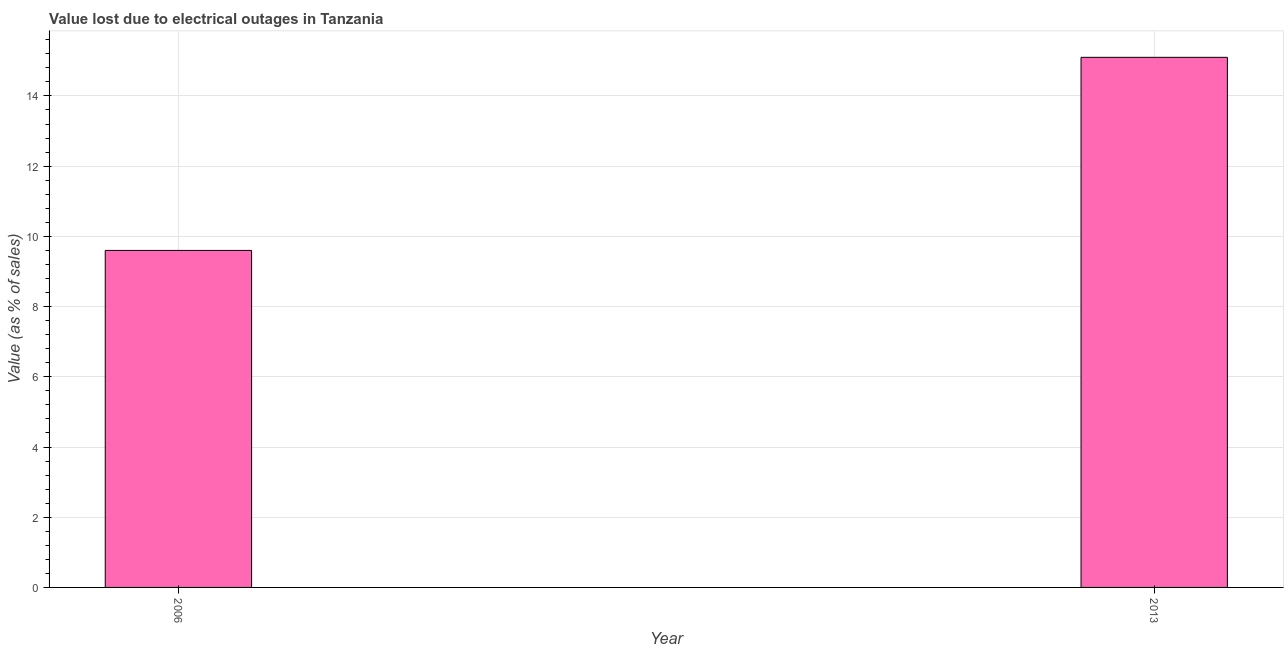Does the graph contain any zero values?
Offer a very short reply. No. Does the graph contain grids?
Offer a terse response. Yes. What is the title of the graph?
Make the answer very short. Value lost due to electrical outages in Tanzania. What is the label or title of the X-axis?
Make the answer very short. Year. What is the label or title of the Y-axis?
Your answer should be compact. Value (as % of sales). Across all years, what is the maximum value lost due to electrical outages?
Make the answer very short. 15.1. In which year was the value lost due to electrical outages maximum?
Provide a short and direct response. 2013. In which year was the value lost due to electrical outages minimum?
Provide a succinct answer. 2006. What is the sum of the value lost due to electrical outages?
Provide a succinct answer. 24.7. What is the average value lost due to electrical outages per year?
Your answer should be compact. 12.35. What is the median value lost due to electrical outages?
Ensure brevity in your answer.  12.35. What is the ratio of the value lost due to electrical outages in 2006 to that in 2013?
Keep it short and to the point. 0.64. Is the value lost due to electrical outages in 2006 less than that in 2013?
Your answer should be compact. Yes. Are all the bars in the graph horizontal?
Give a very brief answer. No. What is the difference between two consecutive major ticks on the Y-axis?
Provide a short and direct response. 2. Are the values on the major ticks of Y-axis written in scientific E-notation?
Ensure brevity in your answer.  No. What is the difference between the Value (as % of sales) in 2006 and 2013?
Provide a succinct answer. -5.5. What is the ratio of the Value (as % of sales) in 2006 to that in 2013?
Give a very brief answer. 0.64. 